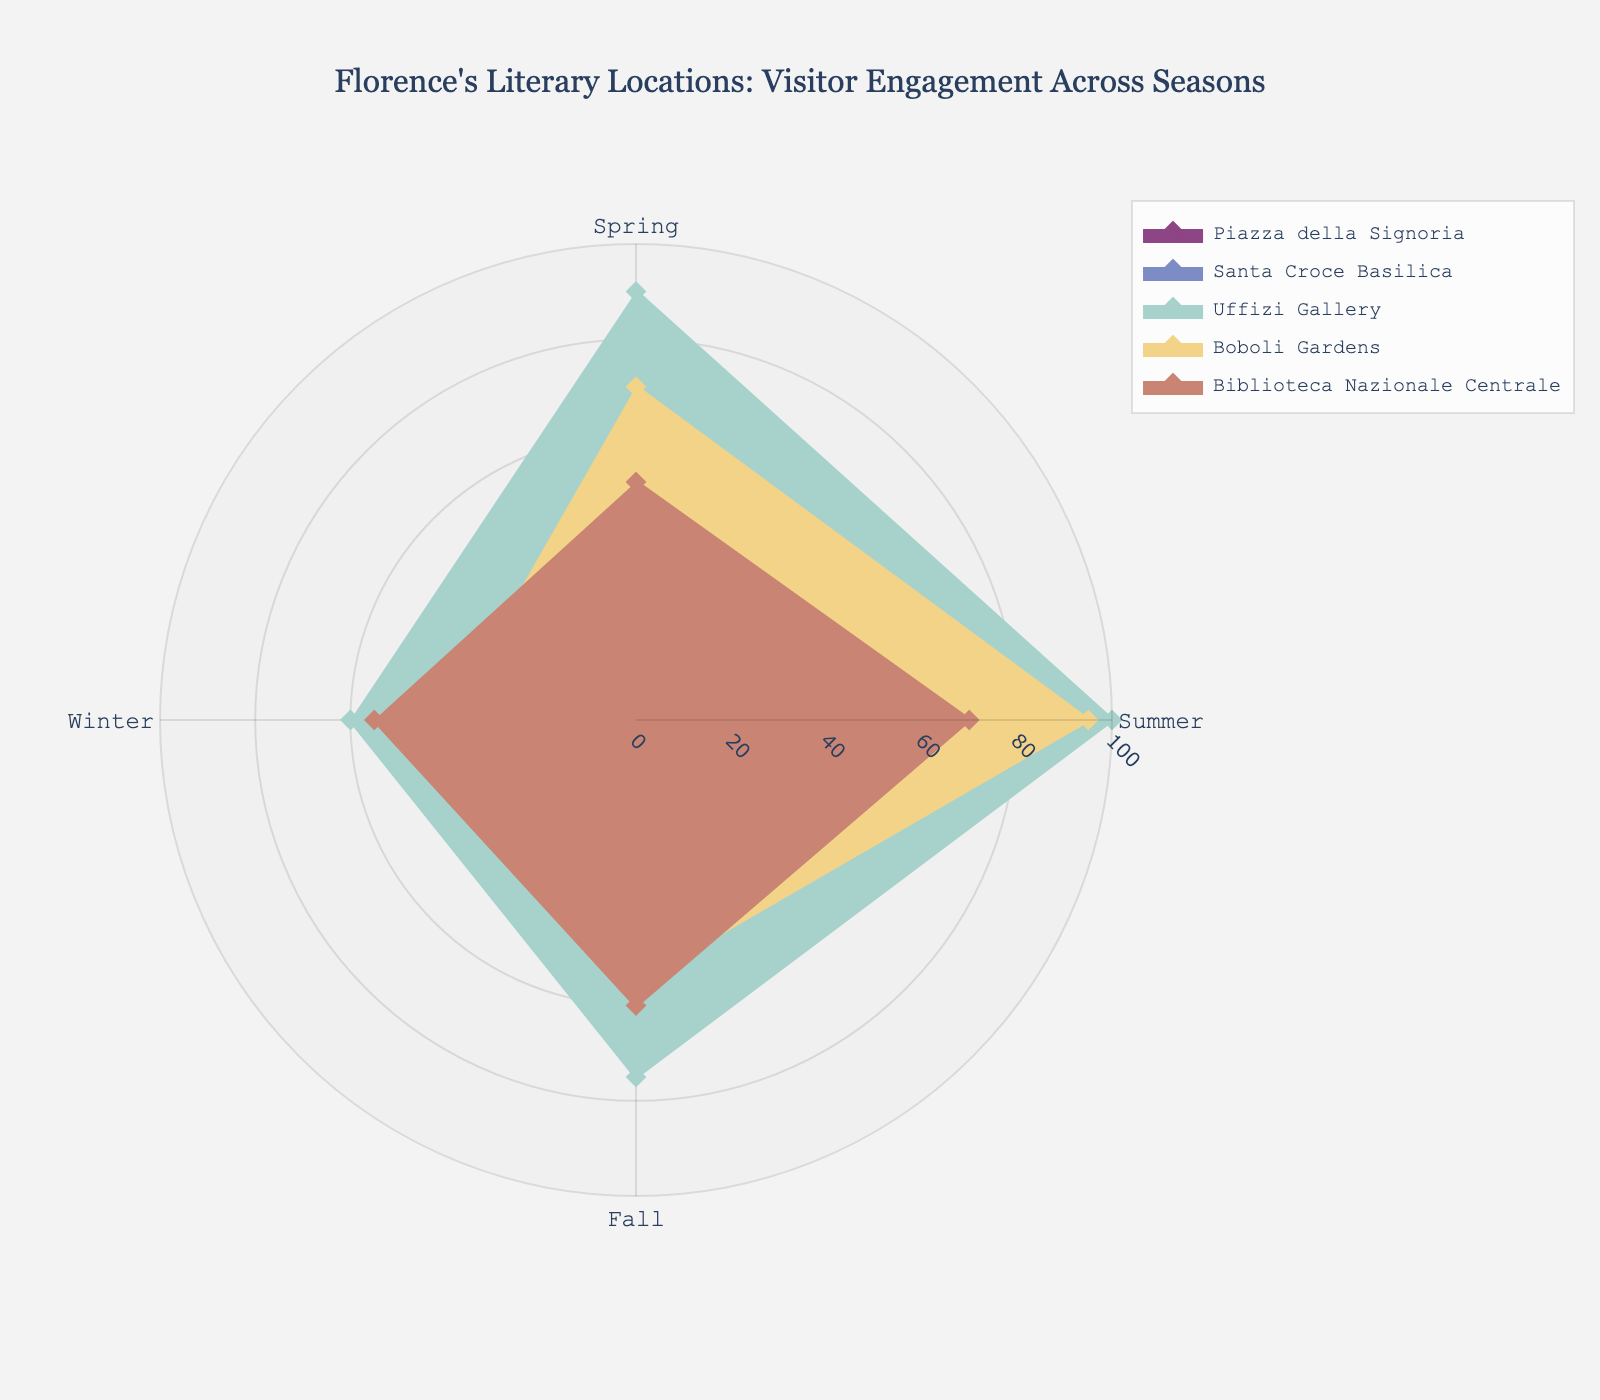What's the title of the figure? The title is located at the top of the chart and provides the overall context of the visualization. The title is "Florence's Literary Locations: Visitor Engagement Across Seasons".
Answer: Florence's Literary Locations: Visitor Engagement Across Seasons How many unique locations are displayed in the figure? To find the number of unique locations, count the number of different names in the legend. The unique locations are Piazza della Signoria, Santa Croce Basilica, Uffizi Gallery, Boboli Gardens, and Biblioteca Nazionale Centrale.
Answer: 5 Which location has the highest visitor engagement during the winter? Look for the highest radial value on the Winter axis (one of the four axes) and identify the corresponding location by checking the color and legend. The highest engagement in winter is at the Uffizi Gallery.
Answer: Uffizi Gallery Which season shows the lowest visitor engagement for Boboli Gardens? Check the radial values for Boboli Gardens on the axes representing Spring, Summer, Fall, and Winter. The lowest engagement is in Winter with a value of 40.
Answer: Winter What is the average visitor engagement for Piazza della Signoria across all seasons? Add the engagement values for all seasons (80 + 95 + 70 + 50) and divide by the number of seasons (4). The average is (80 + 95 + 70 + 50) / 4 = 73.75
Answer: 73.75 Compare the visitor engagement between Santa Croce Basilica and Biblioteca Nazionale Centrale during Summer. Which location has more engagement? Look at the radial values for Santa Croce Basilica and Biblioteca Nazionale Centrale on the Summer axis. Santa Croce Basilica has 85, and Biblioteca Nazionale Centrale has 70.
Answer: Santa Croce Basilica Which location has the most significant variation in visitor engagement across the seasons? To find the location with the most significant variation, calculate the range (max value - min value) for each location. Uffizi Gallery has values spanning from 100 to 60, a maximum range of 40.
Answer: Uffizi Gallery Is the visitor engagement higher in Spring or Fall for Piazza della Signoria? Compare the radial values for Piazza della Signoria on the Spring and Fall axes. Spring has 80, Fall has 70.
Answer: Spring Which two seasons exhibit the closest visitor engagement values for Biblioteca Nazionale Centrale? Compare the radial values for Biblioteca Nazionale Centrale across the four seasons. Spring has 50, Summer has 70, Fall has 60, Winter has 55. Fall and Winter have closer engagement values (60 and 55).
Answer: Fall and Winter 